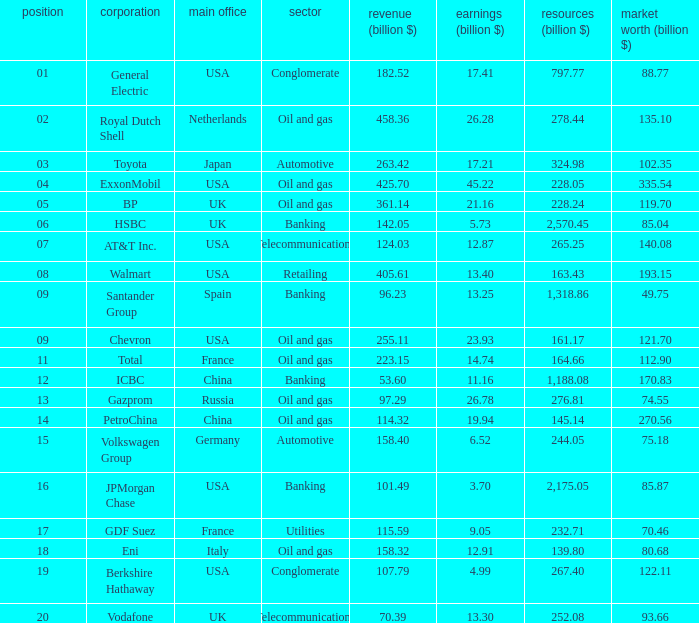Name the Sales (billion $) which have a Company of exxonmobil? 425.7. 